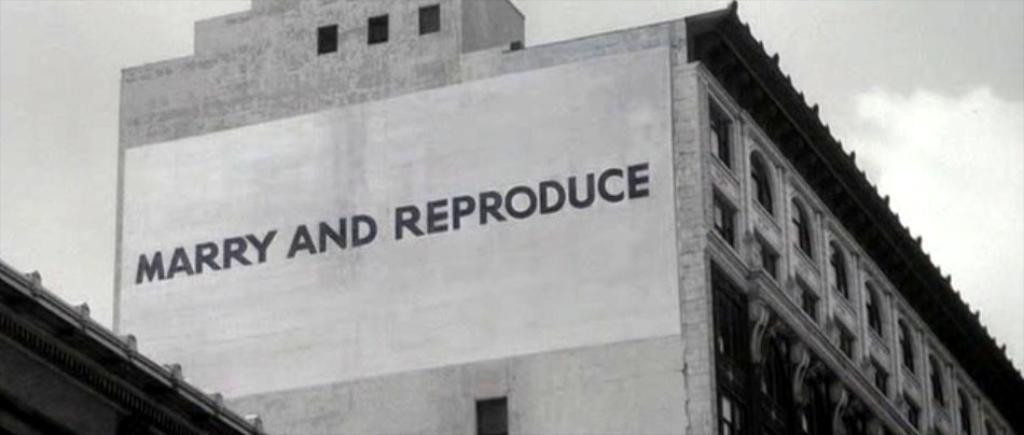Please provide a concise description of this image. In this image there are two buildings , there is a board on the building, sky. 